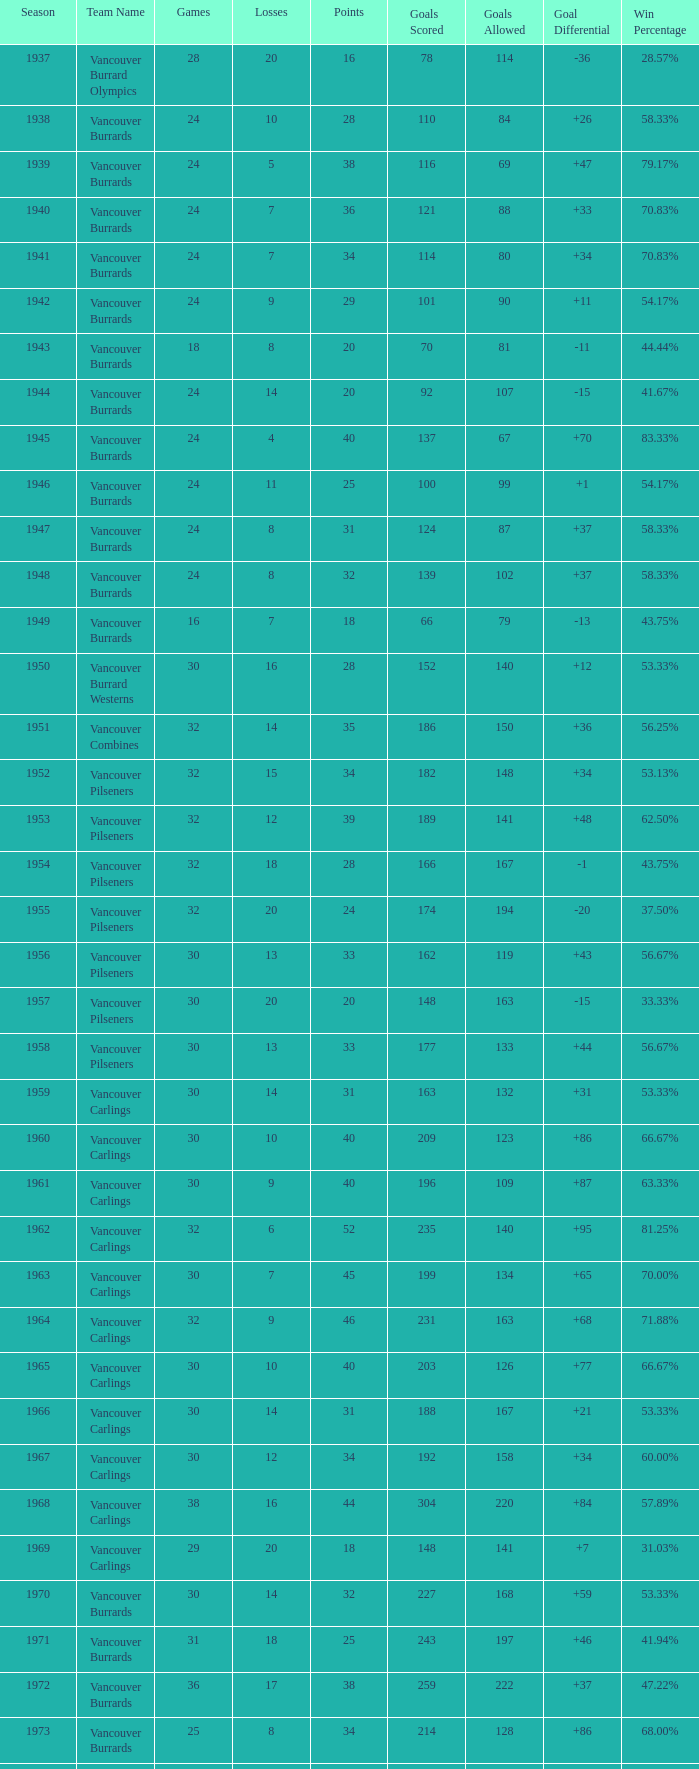What's the total losses for the vancouver burrards in the 1947 season with fewer than 24 games? 0.0. 